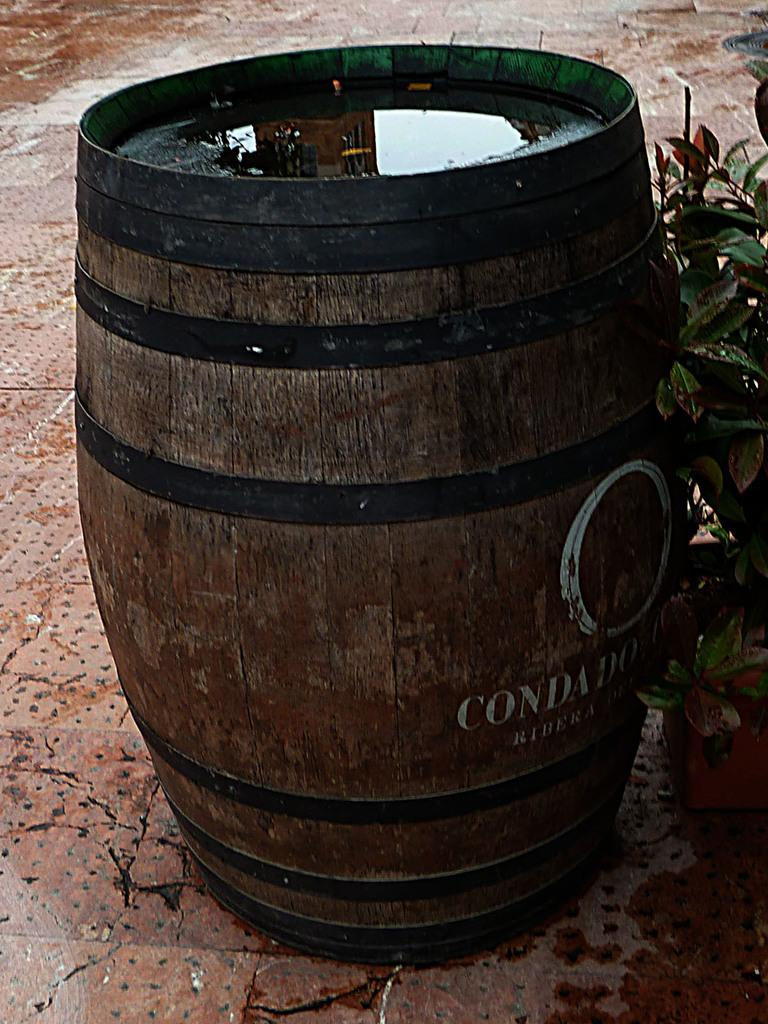Provide a one-sentence caption for the provided image. A Condado barrel filled with water is sitting on the rainy sidewalk. 